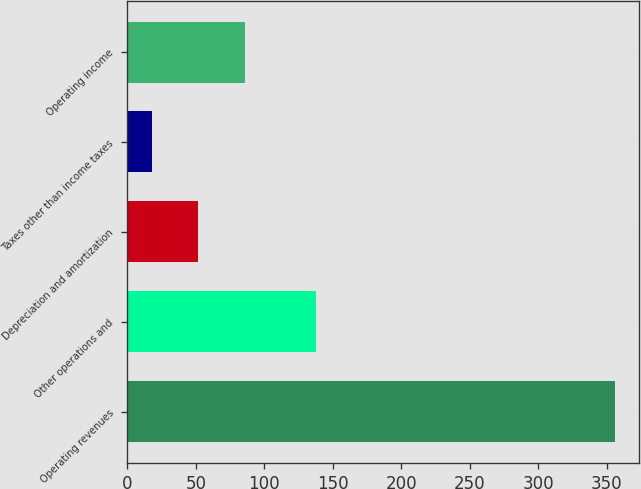<chart> <loc_0><loc_0><loc_500><loc_500><bar_chart><fcel>Operating revenues<fcel>Other operations and<fcel>Depreciation and amortization<fcel>Taxes other than income taxes<fcel>Operating income<nl><fcel>356<fcel>138<fcel>51.8<fcel>18<fcel>85.6<nl></chart> 